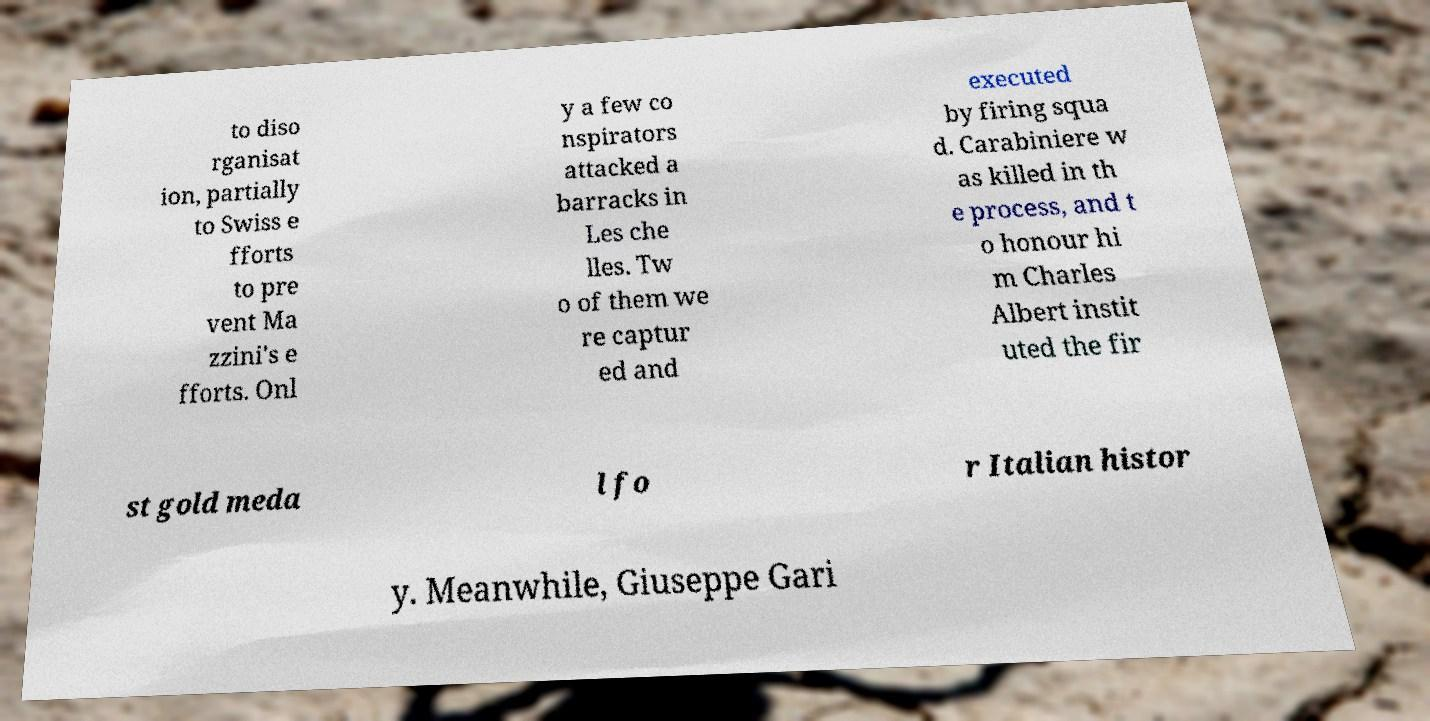Could you extract and type out the text from this image? to diso rganisat ion, partially to Swiss e fforts to pre vent Ma zzini's e fforts. Onl y a few co nspirators attacked a barracks in Les che lles. Tw o of them we re captur ed and executed by firing squa d. Carabiniere w as killed in th e process, and t o honour hi m Charles Albert instit uted the fir st gold meda l fo r Italian histor y. Meanwhile, Giuseppe Gari 